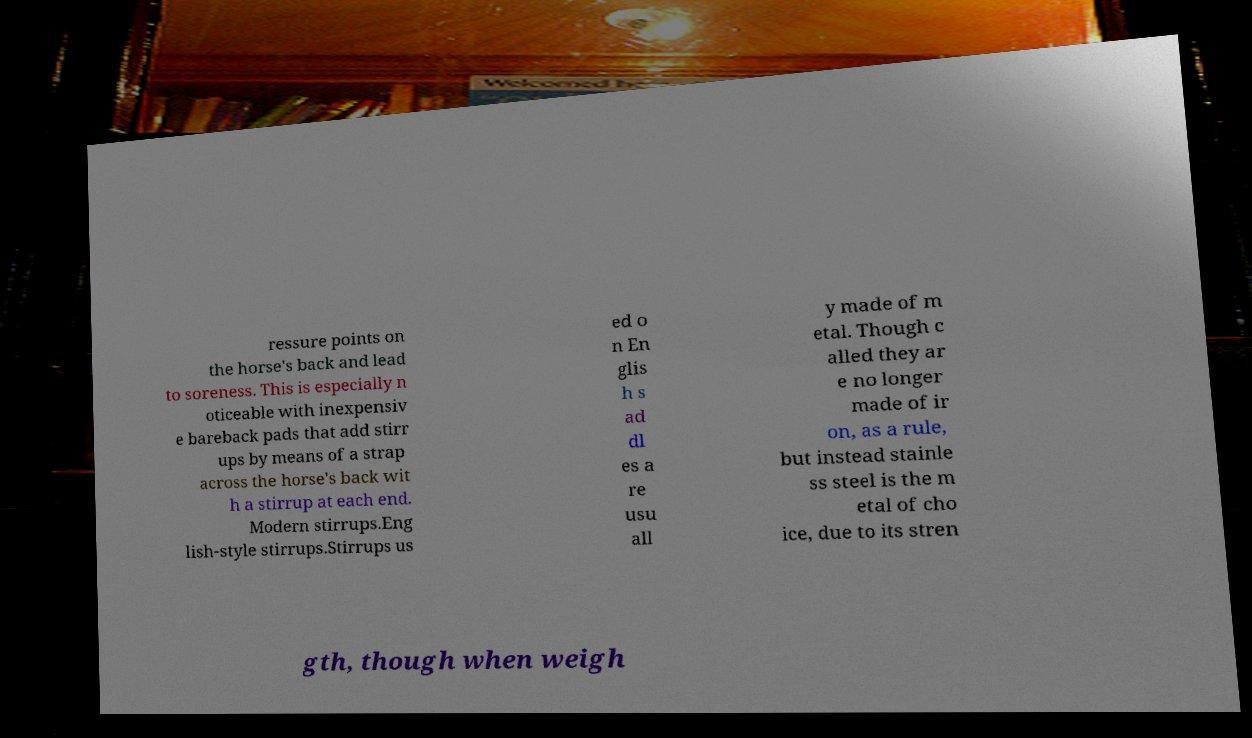I need the written content from this picture converted into text. Can you do that? ressure points on the horse's back and lead to soreness. This is especially n oticeable with inexpensiv e bareback pads that add stirr ups by means of a strap across the horse's back wit h a stirrup at each end. Modern stirrups.Eng lish-style stirrups.Stirrups us ed o n En glis h s ad dl es a re usu all y made of m etal. Though c alled they ar e no longer made of ir on, as a rule, but instead stainle ss steel is the m etal of cho ice, due to its stren gth, though when weigh 